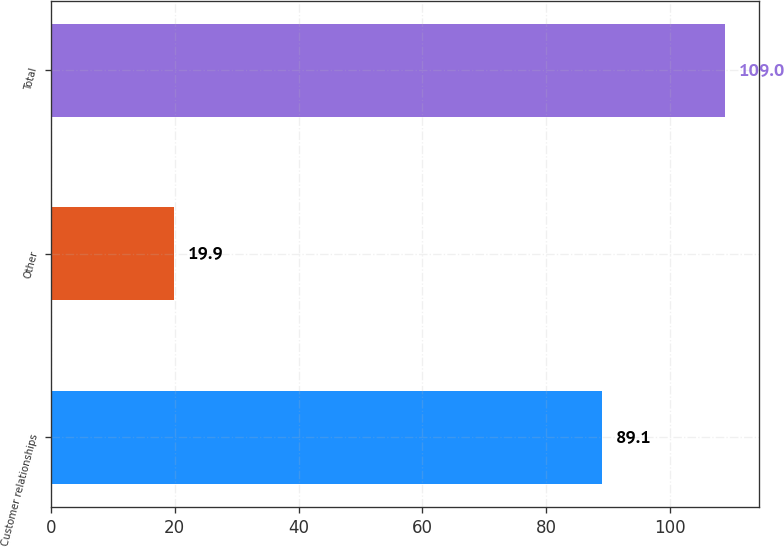<chart> <loc_0><loc_0><loc_500><loc_500><bar_chart><fcel>Customer relationships<fcel>Other<fcel>Total<nl><fcel>89.1<fcel>19.9<fcel>109<nl></chart> 